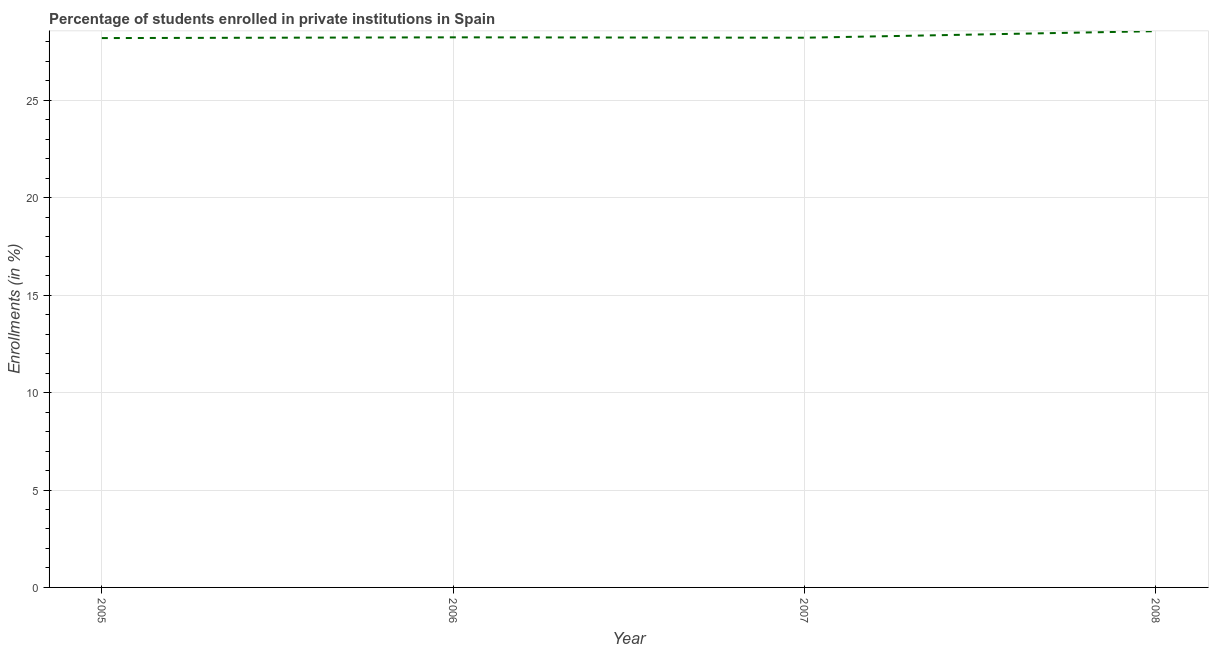What is the enrollments in private institutions in 2005?
Make the answer very short. 28.2. Across all years, what is the maximum enrollments in private institutions?
Offer a terse response. 28.56. Across all years, what is the minimum enrollments in private institutions?
Provide a short and direct response. 28.2. What is the sum of the enrollments in private institutions?
Make the answer very short. 113.21. What is the difference between the enrollments in private institutions in 2006 and 2008?
Your response must be concise. -0.32. What is the average enrollments in private institutions per year?
Your answer should be compact. 28.3. What is the median enrollments in private institutions?
Provide a succinct answer. 28.23. What is the ratio of the enrollments in private institutions in 2005 to that in 2008?
Make the answer very short. 0.99. Is the enrollments in private institutions in 2006 less than that in 2007?
Keep it short and to the point. No. Is the difference between the enrollments in private institutions in 2005 and 2008 greater than the difference between any two years?
Ensure brevity in your answer.  Yes. What is the difference between the highest and the second highest enrollments in private institutions?
Give a very brief answer. 0.32. Is the sum of the enrollments in private institutions in 2005 and 2008 greater than the maximum enrollments in private institutions across all years?
Make the answer very short. Yes. What is the difference between the highest and the lowest enrollments in private institutions?
Give a very brief answer. 0.35. In how many years, is the enrollments in private institutions greater than the average enrollments in private institutions taken over all years?
Provide a short and direct response. 1. How many years are there in the graph?
Your response must be concise. 4. Does the graph contain grids?
Make the answer very short. Yes. What is the title of the graph?
Offer a very short reply. Percentage of students enrolled in private institutions in Spain. What is the label or title of the Y-axis?
Make the answer very short. Enrollments (in %). What is the Enrollments (in %) in 2005?
Ensure brevity in your answer.  28.2. What is the Enrollments (in %) of 2006?
Your response must be concise. 28.24. What is the Enrollments (in %) of 2007?
Your response must be concise. 28.22. What is the Enrollments (in %) in 2008?
Provide a short and direct response. 28.56. What is the difference between the Enrollments (in %) in 2005 and 2006?
Provide a short and direct response. -0.04. What is the difference between the Enrollments (in %) in 2005 and 2007?
Give a very brief answer. -0.02. What is the difference between the Enrollments (in %) in 2005 and 2008?
Give a very brief answer. -0.35. What is the difference between the Enrollments (in %) in 2006 and 2007?
Ensure brevity in your answer.  0.02. What is the difference between the Enrollments (in %) in 2006 and 2008?
Your response must be concise. -0.32. What is the difference between the Enrollments (in %) in 2007 and 2008?
Your response must be concise. -0.34. What is the ratio of the Enrollments (in %) in 2005 to that in 2007?
Your response must be concise. 1. What is the ratio of the Enrollments (in %) in 2006 to that in 2008?
Offer a very short reply. 0.99. What is the ratio of the Enrollments (in %) in 2007 to that in 2008?
Ensure brevity in your answer.  0.99. 